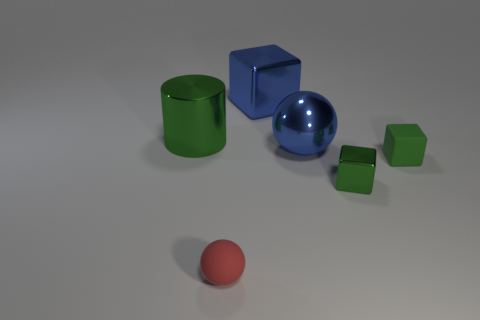Is the matte block the same color as the large cylinder?
Provide a short and direct response. Yes. What is the material of the big object that is the same color as the big sphere?
Make the answer very short. Metal. Is there a big metal cube of the same color as the large sphere?
Offer a very short reply. Yes. What is the thing that is to the right of the small green metallic object made of?
Provide a succinct answer. Rubber. What number of other objects are the same shape as the green rubber thing?
Make the answer very short. 2. Do the small shiny thing and the green rubber thing have the same shape?
Your answer should be very brief. Yes. There is a small green shiny cube; are there any tiny objects right of it?
Keep it short and to the point. Yes. How many objects are small blue metal spheres or big things?
Keep it short and to the point. 3. How many things are both in front of the large green cylinder and to the right of the small red rubber thing?
Your answer should be compact. 3. There is a matte object that is in front of the small matte cube; is its size the same as the green metallic thing in front of the big cylinder?
Your response must be concise. Yes. 